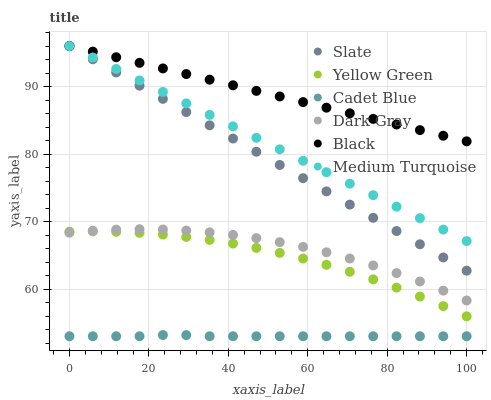Does Cadet Blue have the minimum area under the curve?
Answer yes or no. Yes. Does Black have the maximum area under the curve?
Answer yes or no. Yes. Does Yellow Green have the minimum area under the curve?
Answer yes or no. No. Does Yellow Green have the maximum area under the curve?
Answer yes or no. No. Is Medium Turquoise the smoothest?
Answer yes or no. Yes. Is Dark Gray the roughest?
Answer yes or no. Yes. Is Yellow Green the smoothest?
Answer yes or no. No. Is Yellow Green the roughest?
Answer yes or no. No. Does Cadet Blue have the lowest value?
Answer yes or no. Yes. Does Yellow Green have the lowest value?
Answer yes or no. No. Does Medium Turquoise have the highest value?
Answer yes or no. Yes. Does Yellow Green have the highest value?
Answer yes or no. No. Is Yellow Green less than Black?
Answer yes or no. Yes. Is Medium Turquoise greater than Yellow Green?
Answer yes or no. Yes. Does Dark Gray intersect Yellow Green?
Answer yes or no. Yes. Is Dark Gray less than Yellow Green?
Answer yes or no. No. Is Dark Gray greater than Yellow Green?
Answer yes or no. No. Does Yellow Green intersect Black?
Answer yes or no. No. 